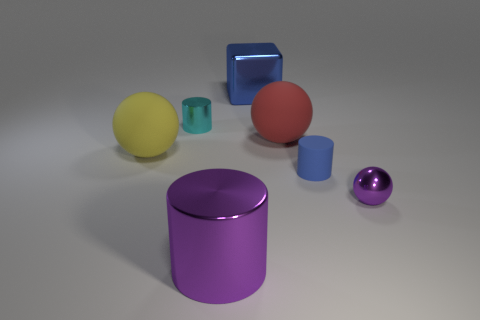What could be the use of these objects in real life? The objects, while depicted as simple geometric shapes, could represent common items. The spheres might be balls or ornaments, the cylinders could be containers or storage solutions, while the cube resembles a box, potentially used for storage or as an abstract furniture piece. 